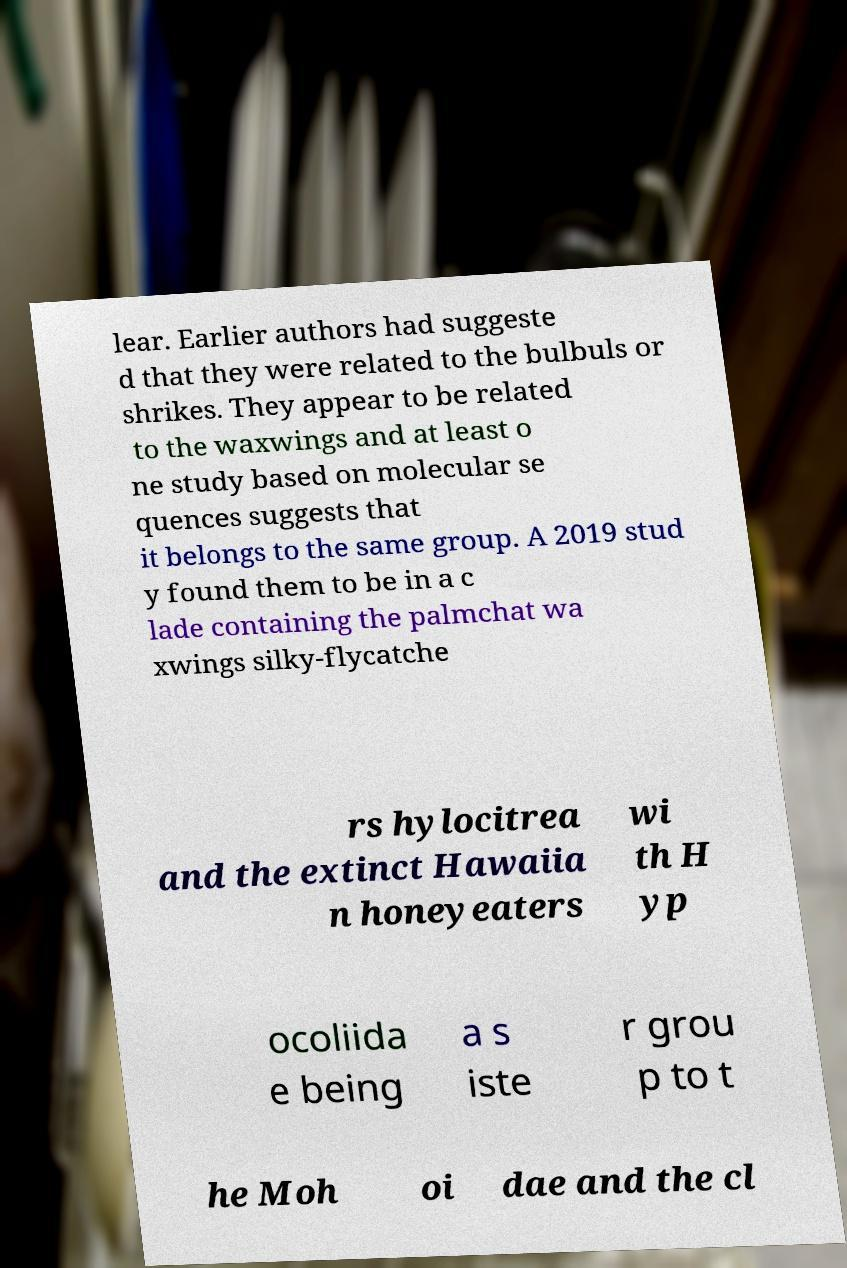Please read and relay the text visible in this image. What does it say? lear. Earlier authors had suggeste d that they were related to the bulbuls or shrikes. They appear to be related to the waxwings and at least o ne study based on molecular se quences suggests that it belongs to the same group. A 2019 stud y found them to be in a c lade containing the palmchat wa xwings silky-flycatche rs hylocitrea and the extinct Hawaiia n honeyeaters wi th H yp ocoliida e being a s iste r grou p to t he Moh oi dae and the cl 